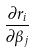<formula> <loc_0><loc_0><loc_500><loc_500>\frac { \partial r _ { i } } { \partial \beta _ { j } }</formula> 